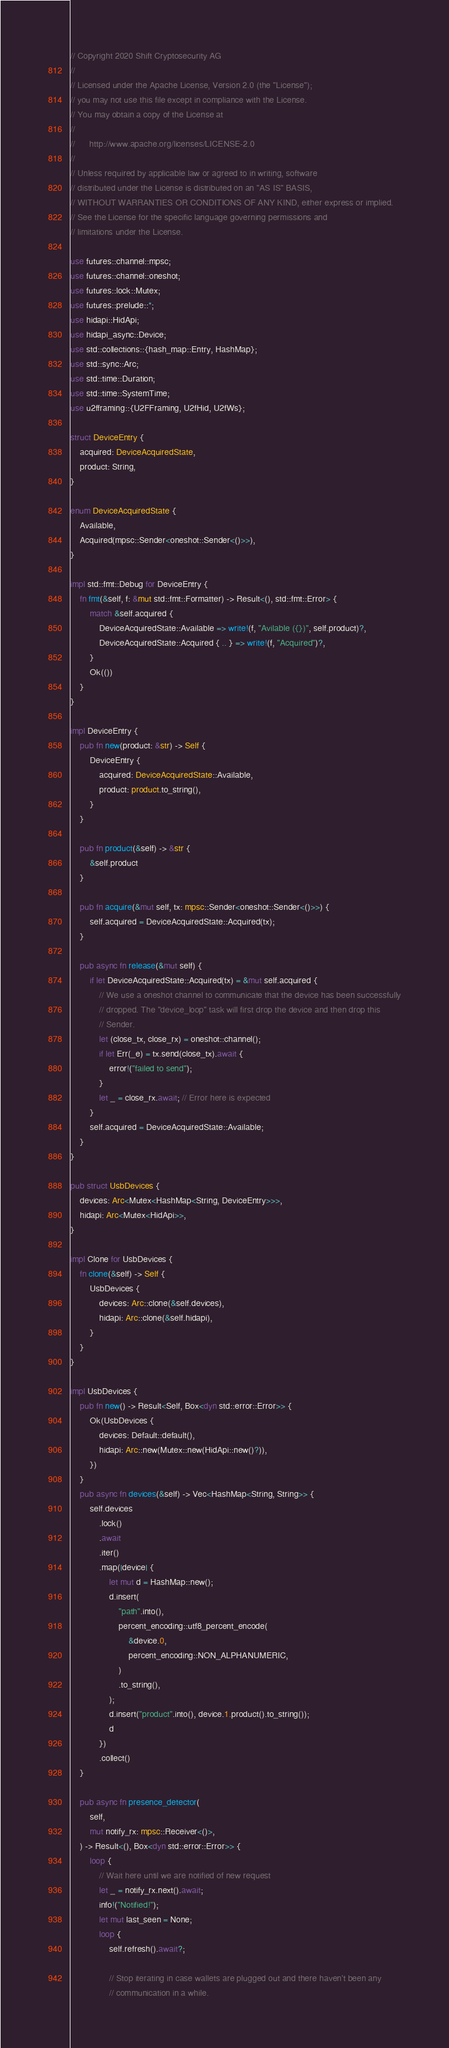<code> <loc_0><loc_0><loc_500><loc_500><_Rust_>// Copyright 2020 Shift Cryptosecurity AG
//
// Licensed under the Apache License, Version 2.0 (the "License");
// you may not use this file except in compliance with the License.
// You may obtain a copy of the License at
//
//      http://www.apache.org/licenses/LICENSE-2.0
//
// Unless required by applicable law or agreed to in writing, software
// distributed under the License is distributed on an "AS IS" BASIS,
// WITHOUT WARRANTIES OR CONDITIONS OF ANY KIND, either express or implied.
// See the License for the specific language governing permissions and
// limitations under the License.

use futures::channel::mpsc;
use futures::channel::oneshot;
use futures::lock::Mutex;
use futures::prelude::*;
use hidapi::HidApi;
use hidapi_async::Device;
use std::collections::{hash_map::Entry, HashMap};
use std::sync::Arc;
use std::time::Duration;
use std::time::SystemTime;
use u2fframing::{U2FFraming, U2fHid, U2fWs};

struct DeviceEntry {
    acquired: DeviceAcquiredState,
    product: String,
}

enum DeviceAcquiredState {
    Available,
    Acquired(mpsc::Sender<oneshot::Sender<()>>),
}

impl std::fmt::Debug for DeviceEntry {
    fn fmt(&self, f: &mut std::fmt::Formatter) -> Result<(), std::fmt::Error> {
        match &self.acquired {
            DeviceAcquiredState::Available => write!(f, "Avilable ({})", self.product)?,
            DeviceAcquiredState::Acquired { .. } => write!(f, "Acquired")?,
        }
        Ok(())
    }
}

impl DeviceEntry {
    pub fn new(product: &str) -> Self {
        DeviceEntry {
            acquired: DeviceAcquiredState::Available,
            product: product.to_string(),
        }
    }

    pub fn product(&self) -> &str {
        &self.product
    }

    pub fn acquire(&mut self, tx: mpsc::Sender<oneshot::Sender<()>>) {
        self.acquired = DeviceAcquiredState::Acquired(tx);
    }

    pub async fn release(&mut self) {
        if let DeviceAcquiredState::Acquired(tx) = &mut self.acquired {
            // We use a oneshot channel to communicate that the device has been successfully
            // dropped. The "device_loop" task will first drop the device and then drop this
            // Sender.
            let (close_tx, close_rx) = oneshot::channel();
            if let Err(_e) = tx.send(close_tx).await {
                error!("failed to send");
            }
            let _ = close_rx.await; // Error here is expected
        }
        self.acquired = DeviceAcquiredState::Available;
    }
}

pub struct UsbDevices {
    devices: Arc<Mutex<HashMap<String, DeviceEntry>>>,
    hidapi: Arc<Mutex<HidApi>>,
}

impl Clone for UsbDevices {
    fn clone(&self) -> Self {
        UsbDevices {
            devices: Arc::clone(&self.devices),
            hidapi: Arc::clone(&self.hidapi),
        }
    }
}

impl UsbDevices {
    pub fn new() -> Result<Self, Box<dyn std::error::Error>> {
        Ok(UsbDevices {
            devices: Default::default(),
            hidapi: Arc::new(Mutex::new(HidApi::new()?)),
        })
    }
    pub async fn devices(&self) -> Vec<HashMap<String, String>> {
        self.devices
            .lock()
            .await
            .iter()
            .map(|device| {
                let mut d = HashMap::new();
                d.insert(
                    "path".into(),
                    percent_encoding::utf8_percent_encode(
                        &device.0,
                        percent_encoding::NON_ALPHANUMERIC,
                    )
                    .to_string(),
                );
                d.insert("product".into(), device.1.product().to_string());
                d
            })
            .collect()
    }

    pub async fn presence_detector(
        self,
        mut notify_rx: mpsc::Receiver<()>,
    ) -> Result<(), Box<dyn std::error::Error>> {
        loop {
            // Wait here until we are notified of new request
            let _ = notify_rx.next().await;
            info!("Notified!");
            let mut last_seen = None;
            loop {
                self.refresh().await?;

                // Stop iterating in case wallets are plugged out and there haven't been any
                // communication in a while.</code> 